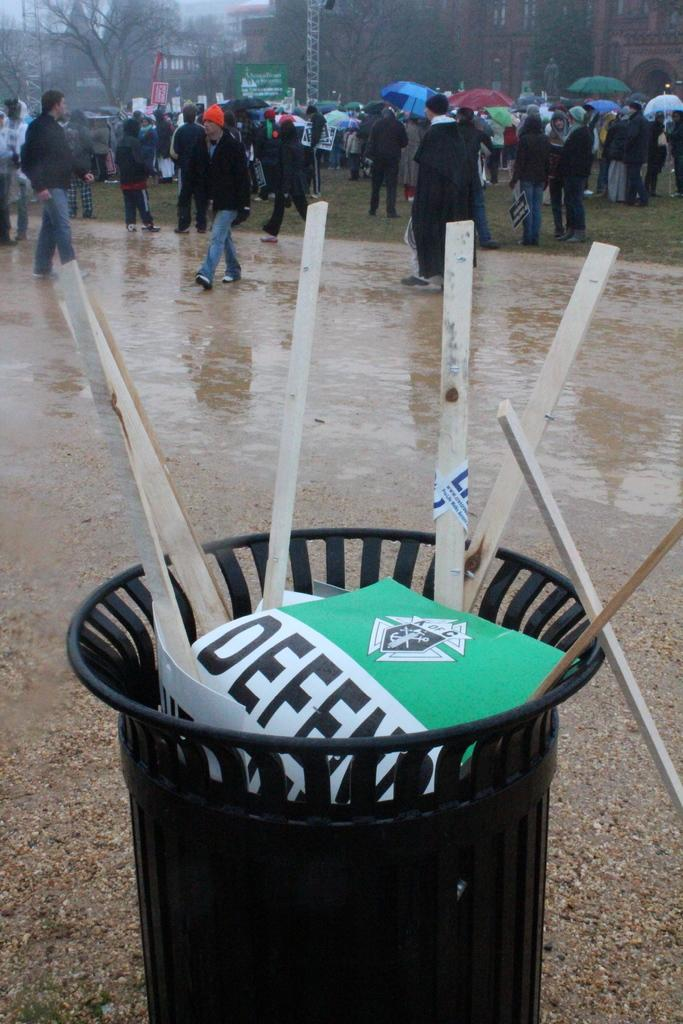Provide a one-sentence caption for the provided image. many people are standing behind a trash can with DEFEND signs in it. 